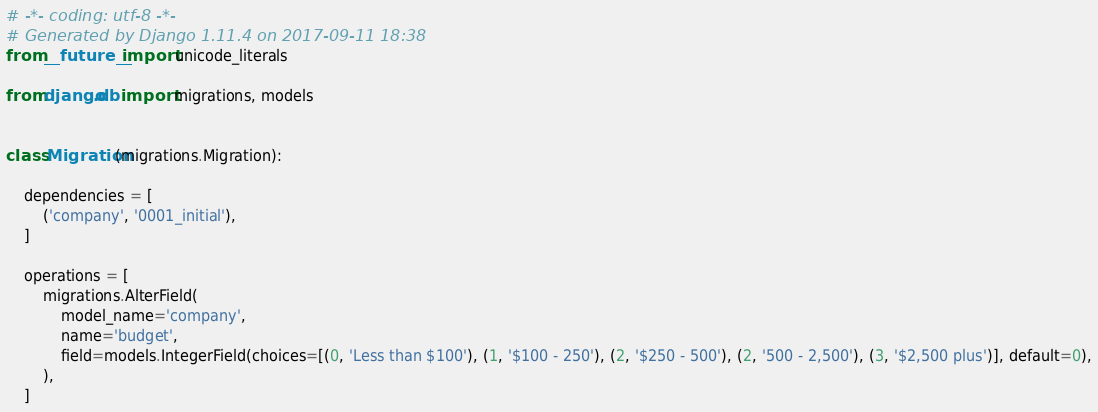Convert code to text. <code><loc_0><loc_0><loc_500><loc_500><_Python_># -*- coding: utf-8 -*-
# Generated by Django 1.11.4 on 2017-09-11 18:38
from __future__ import unicode_literals

from django.db import migrations, models


class Migration(migrations.Migration):

    dependencies = [
        ('company', '0001_initial'),
    ]

    operations = [
        migrations.AlterField(
            model_name='company',
            name='budget',
            field=models.IntegerField(choices=[(0, 'Less than $100'), (1, '$100 - 250'), (2, '$250 - 500'), (2, '500 - 2,500'), (3, '$2,500 plus')], default=0),
        ),
    ]
</code> 